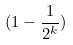<formula> <loc_0><loc_0><loc_500><loc_500>( 1 - \frac { 1 } { 2 ^ { k } } )</formula> 